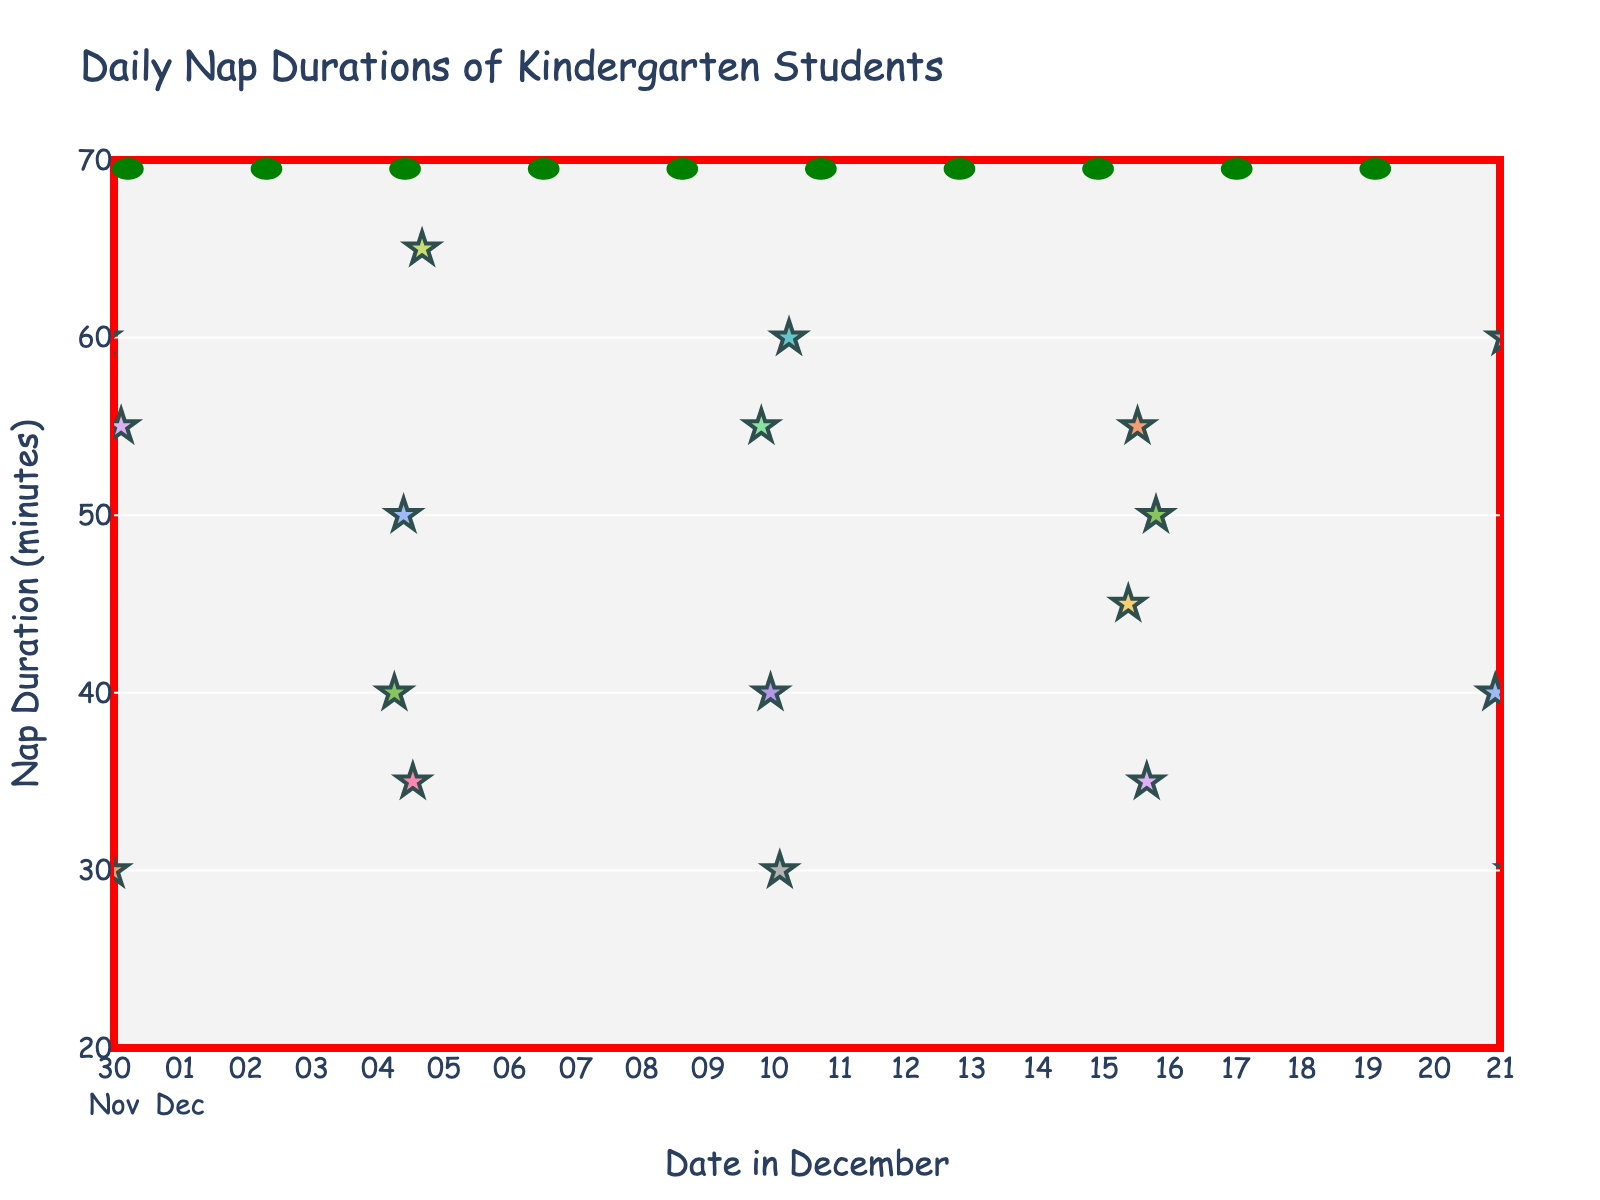Which student had the highest nap duration on December 1st? To find the answer, look for the data point with the highest y-value on December 1st. The highest point is 60 minutes by Liam.
Answer: Liam How many students took a nap on December 5th? Count the number of data points located on December 5th. There are four data points for that day.
Answer: 4 What is the average nap duration of students on December 10th? Sum the nap durations on December 10th (55 + 40 + 30 + 60) and divide by the number of students (4). The calculations are (55 + 40 + 30 + 60) = 185, then 185 / 4 = 46.25.
Answer: 46.25 Which date had the least variation in nap durations? Observe the spread of data points on each date. December 1st and December 20th both show closer values, but December 1st has a narrower range (30 to 60 minutes), making it less varied.
Answer: December 1st Who took the shortest nap on December 20th? Identify the lowest data point on December 20th. The shortest nap was 30 minutes by Abigail.
Answer: Abigail What is the median nap duration on December 15th? Arrange the nap durations of December 15th (45, 55, 35, 50) in ascending order (35, 45, 50, 55) and find the median. The median is the average of the two middle numbers: (45 + 50) / 2 = 47.5.
Answer: 47.5 Compare the nap duration trends between Emma and Henry. Who had more consistent nap durations? Emma has only one data point on December 1st (45 minutes). Henry has one data point on December 20th (55 minutes). Both have a single datapoint each; thus, they both have consistent durations individually but no trend to compare.
Answer: Both equally consistent How does the variability of nap durations on December 10th compare to December 15th? Calculate the range for both dates. December 10th: 60 - 30 = 30 minutes. December 15th: 55 - 35 = 20 minutes. December 10th shows more variability.
Answer: December 10th more variable Which student had the most varied nap durations over the month? Assess the range across days for each student. For example, Mason's range is from 65 to 65 (same day, no variation). Compare this for other students, notably notice that Emma and Henry only have a single data point each, and others vary more. Upon reviewing, Oliver's range is from 50 on December 5th, with no variations.
Answer: None 